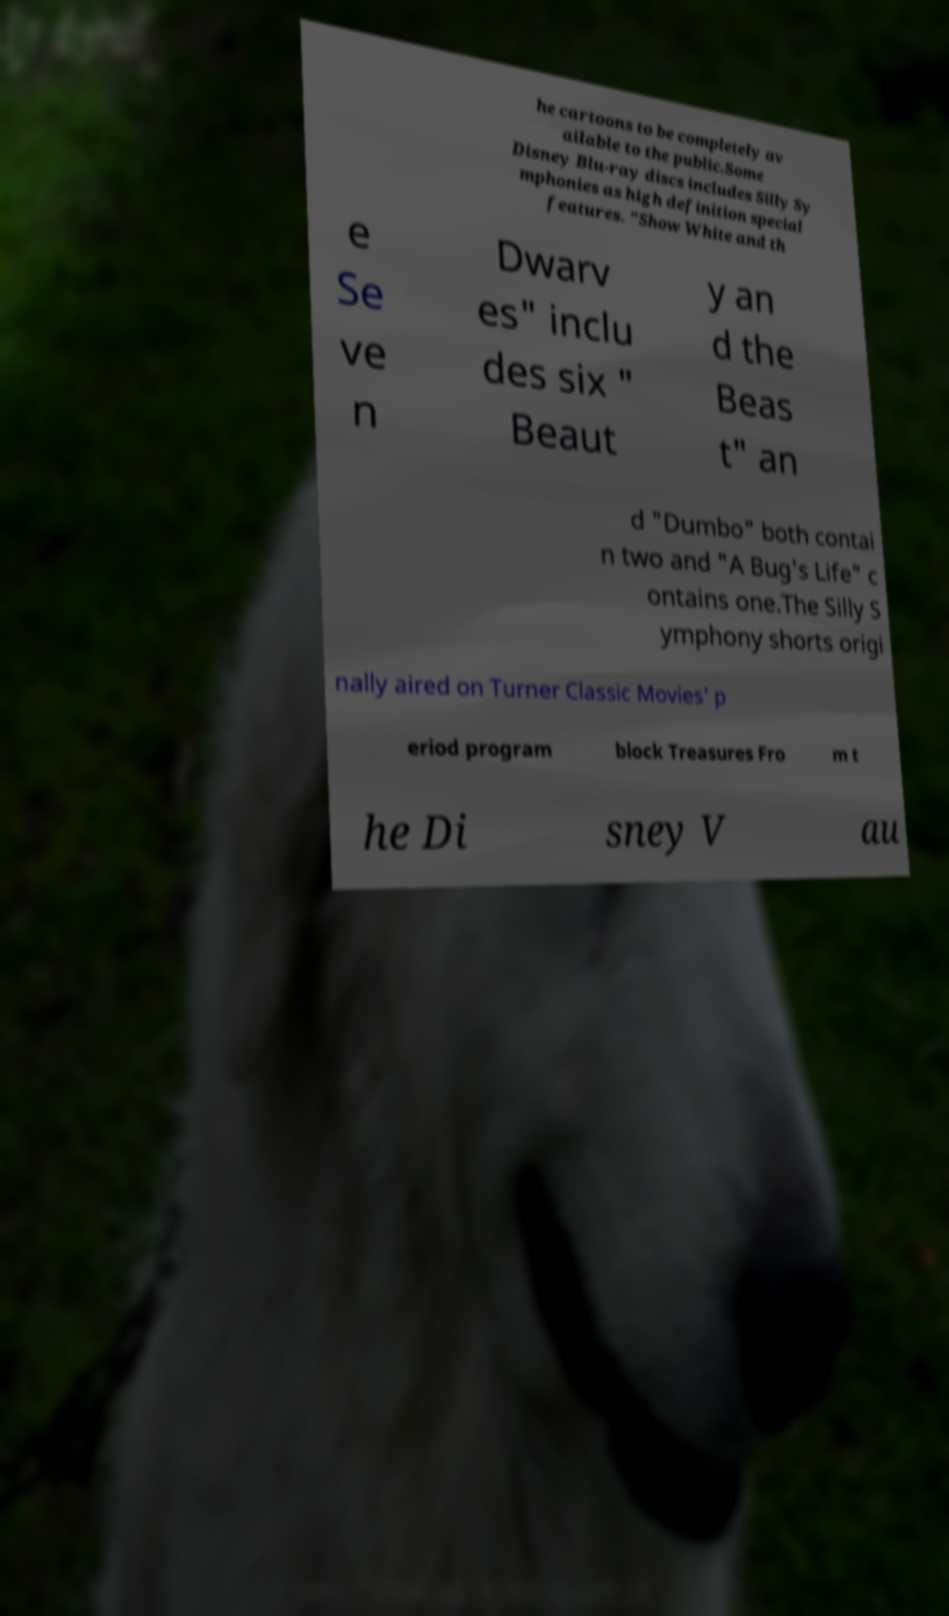Could you assist in decoding the text presented in this image and type it out clearly? he cartoons to be completely av ailable to the public.Some Disney Blu-ray discs includes Silly Sy mphonies as high definition special features. "Show White and th e Se ve n Dwarv es" inclu des six " Beaut y an d the Beas t" an d "Dumbo" both contai n two and "A Bug's Life" c ontains one.The Silly S ymphony shorts origi nally aired on Turner Classic Movies' p eriod program block Treasures Fro m t he Di sney V au 